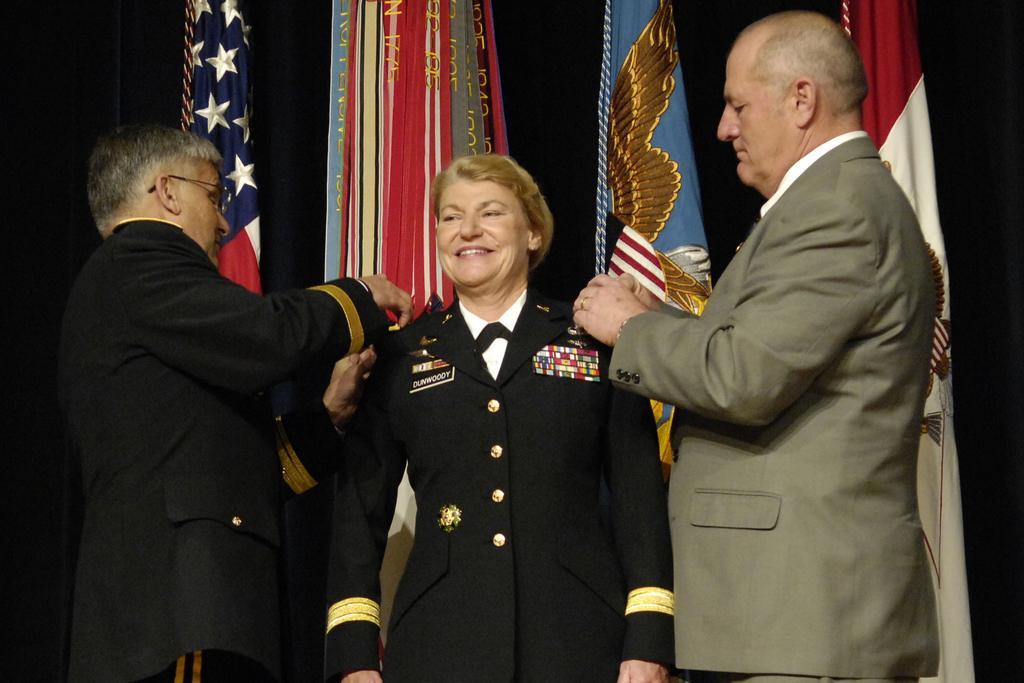Could you give a brief overview of what you see in this image? In this image I can see three persons are standing in the front. I can see the left two are wearing uniforms and the third one is wearing formal dress. In the background I can see few flags and in the front I can see smile on her face. 